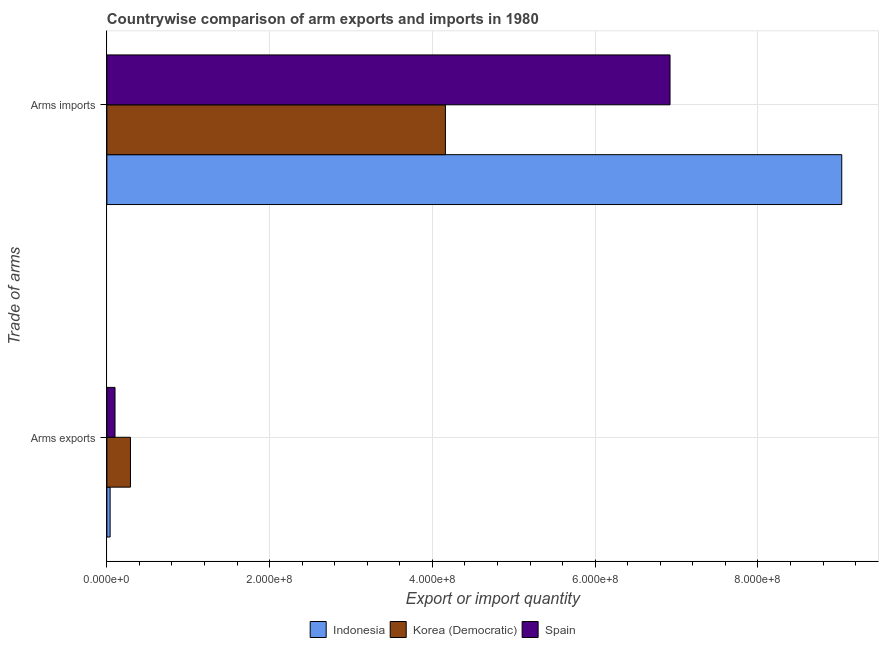How many different coloured bars are there?
Ensure brevity in your answer.  3. How many groups of bars are there?
Provide a succinct answer. 2. Are the number of bars per tick equal to the number of legend labels?
Offer a very short reply. Yes. How many bars are there on the 2nd tick from the bottom?
Keep it short and to the point. 3. What is the label of the 1st group of bars from the top?
Offer a terse response. Arms imports. What is the arms exports in Korea (Democratic)?
Provide a succinct answer. 2.90e+07. Across all countries, what is the maximum arms imports?
Ensure brevity in your answer.  9.03e+08. Across all countries, what is the minimum arms imports?
Offer a very short reply. 4.16e+08. In which country was the arms exports minimum?
Your answer should be very brief. Indonesia. What is the total arms imports in the graph?
Give a very brief answer. 2.01e+09. What is the difference between the arms imports in Spain and that in Korea (Democratic)?
Your response must be concise. 2.76e+08. What is the difference between the arms exports in Korea (Democratic) and the arms imports in Spain?
Provide a succinct answer. -6.63e+08. What is the average arms exports per country?
Your answer should be very brief. 1.43e+07. What is the difference between the arms exports and arms imports in Korea (Democratic)?
Your response must be concise. -3.87e+08. What is the ratio of the arms imports in Spain to that in Indonesia?
Offer a very short reply. 0.77. Is the arms exports in Korea (Democratic) less than that in Indonesia?
Your answer should be compact. No. What does the 2nd bar from the top in Arms exports represents?
Provide a short and direct response. Korea (Democratic). What does the 2nd bar from the bottom in Arms imports represents?
Offer a terse response. Korea (Democratic). Are all the bars in the graph horizontal?
Your answer should be very brief. Yes. What is the difference between two consecutive major ticks on the X-axis?
Make the answer very short. 2.00e+08. Are the values on the major ticks of X-axis written in scientific E-notation?
Ensure brevity in your answer.  Yes. Where does the legend appear in the graph?
Keep it short and to the point. Bottom center. How many legend labels are there?
Your answer should be compact. 3. What is the title of the graph?
Your response must be concise. Countrywise comparison of arm exports and imports in 1980. What is the label or title of the X-axis?
Keep it short and to the point. Export or import quantity. What is the label or title of the Y-axis?
Give a very brief answer. Trade of arms. What is the Export or import quantity in Korea (Democratic) in Arms exports?
Give a very brief answer. 2.90e+07. What is the Export or import quantity in Spain in Arms exports?
Make the answer very short. 1.00e+07. What is the Export or import quantity in Indonesia in Arms imports?
Provide a short and direct response. 9.03e+08. What is the Export or import quantity of Korea (Democratic) in Arms imports?
Provide a short and direct response. 4.16e+08. What is the Export or import quantity in Spain in Arms imports?
Offer a very short reply. 6.92e+08. Across all Trade of arms, what is the maximum Export or import quantity of Indonesia?
Offer a very short reply. 9.03e+08. Across all Trade of arms, what is the maximum Export or import quantity of Korea (Democratic)?
Ensure brevity in your answer.  4.16e+08. Across all Trade of arms, what is the maximum Export or import quantity of Spain?
Keep it short and to the point. 6.92e+08. Across all Trade of arms, what is the minimum Export or import quantity in Korea (Democratic)?
Offer a terse response. 2.90e+07. What is the total Export or import quantity of Indonesia in the graph?
Provide a short and direct response. 9.07e+08. What is the total Export or import quantity of Korea (Democratic) in the graph?
Your response must be concise. 4.45e+08. What is the total Export or import quantity of Spain in the graph?
Your answer should be very brief. 7.02e+08. What is the difference between the Export or import quantity of Indonesia in Arms exports and that in Arms imports?
Provide a short and direct response. -8.99e+08. What is the difference between the Export or import quantity of Korea (Democratic) in Arms exports and that in Arms imports?
Provide a succinct answer. -3.87e+08. What is the difference between the Export or import quantity in Spain in Arms exports and that in Arms imports?
Your answer should be compact. -6.82e+08. What is the difference between the Export or import quantity in Indonesia in Arms exports and the Export or import quantity in Korea (Democratic) in Arms imports?
Provide a succinct answer. -4.12e+08. What is the difference between the Export or import quantity of Indonesia in Arms exports and the Export or import quantity of Spain in Arms imports?
Provide a succinct answer. -6.88e+08. What is the difference between the Export or import quantity in Korea (Democratic) in Arms exports and the Export or import quantity in Spain in Arms imports?
Keep it short and to the point. -6.63e+08. What is the average Export or import quantity in Indonesia per Trade of arms?
Your response must be concise. 4.54e+08. What is the average Export or import quantity of Korea (Democratic) per Trade of arms?
Your answer should be very brief. 2.22e+08. What is the average Export or import quantity in Spain per Trade of arms?
Your answer should be very brief. 3.51e+08. What is the difference between the Export or import quantity in Indonesia and Export or import quantity in Korea (Democratic) in Arms exports?
Provide a succinct answer. -2.50e+07. What is the difference between the Export or import quantity in Indonesia and Export or import quantity in Spain in Arms exports?
Offer a terse response. -6.00e+06. What is the difference between the Export or import quantity in Korea (Democratic) and Export or import quantity in Spain in Arms exports?
Keep it short and to the point. 1.90e+07. What is the difference between the Export or import quantity in Indonesia and Export or import quantity in Korea (Democratic) in Arms imports?
Keep it short and to the point. 4.87e+08. What is the difference between the Export or import quantity of Indonesia and Export or import quantity of Spain in Arms imports?
Your answer should be compact. 2.11e+08. What is the difference between the Export or import quantity of Korea (Democratic) and Export or import quantity of Spain in Arms imports?
Offer a terse response. -2.76e+08. What is the ratio of the Export or import quantity in Indonesia in Arms exports to that in Arms imports?
Make the answer very short. 0. What is the ratio of the Export or import quantity in Korea (Democratic) in Arms exports to that in Arms imports?
Provide a short and direct response. 0.07. What is the ratio of the Export or import quantity in Spain in Arms exports to that in Arms imports?
Ensure brevity in your answer.  0.01. What is the difference between the highest and the second highest Export or import quantity in Indonesia?
Your answer should be compact. 8.99e+08. What is the difference between the highest and the second highest Export or import quantity of Korea (Democratic)?
Provide a short and direct response. 3.87e+08. What is the difference between the highest and the second highest Export or import quantity of Spain?
Keep it short and to the point. 6.82e+08. What is the difference between the highest and the lowest Export or import quantity of Indonesia?
Give a very brief answer. 8.99e+08. What is the difference between the highest and the lowest Export or import quantity of Korea (Democratic)?
Your response must be concise. 3.87e+08. What is the difference between the highest and the lowest Export or import quantity in Spain?
Your answer should be compact. 6.82e+08. 